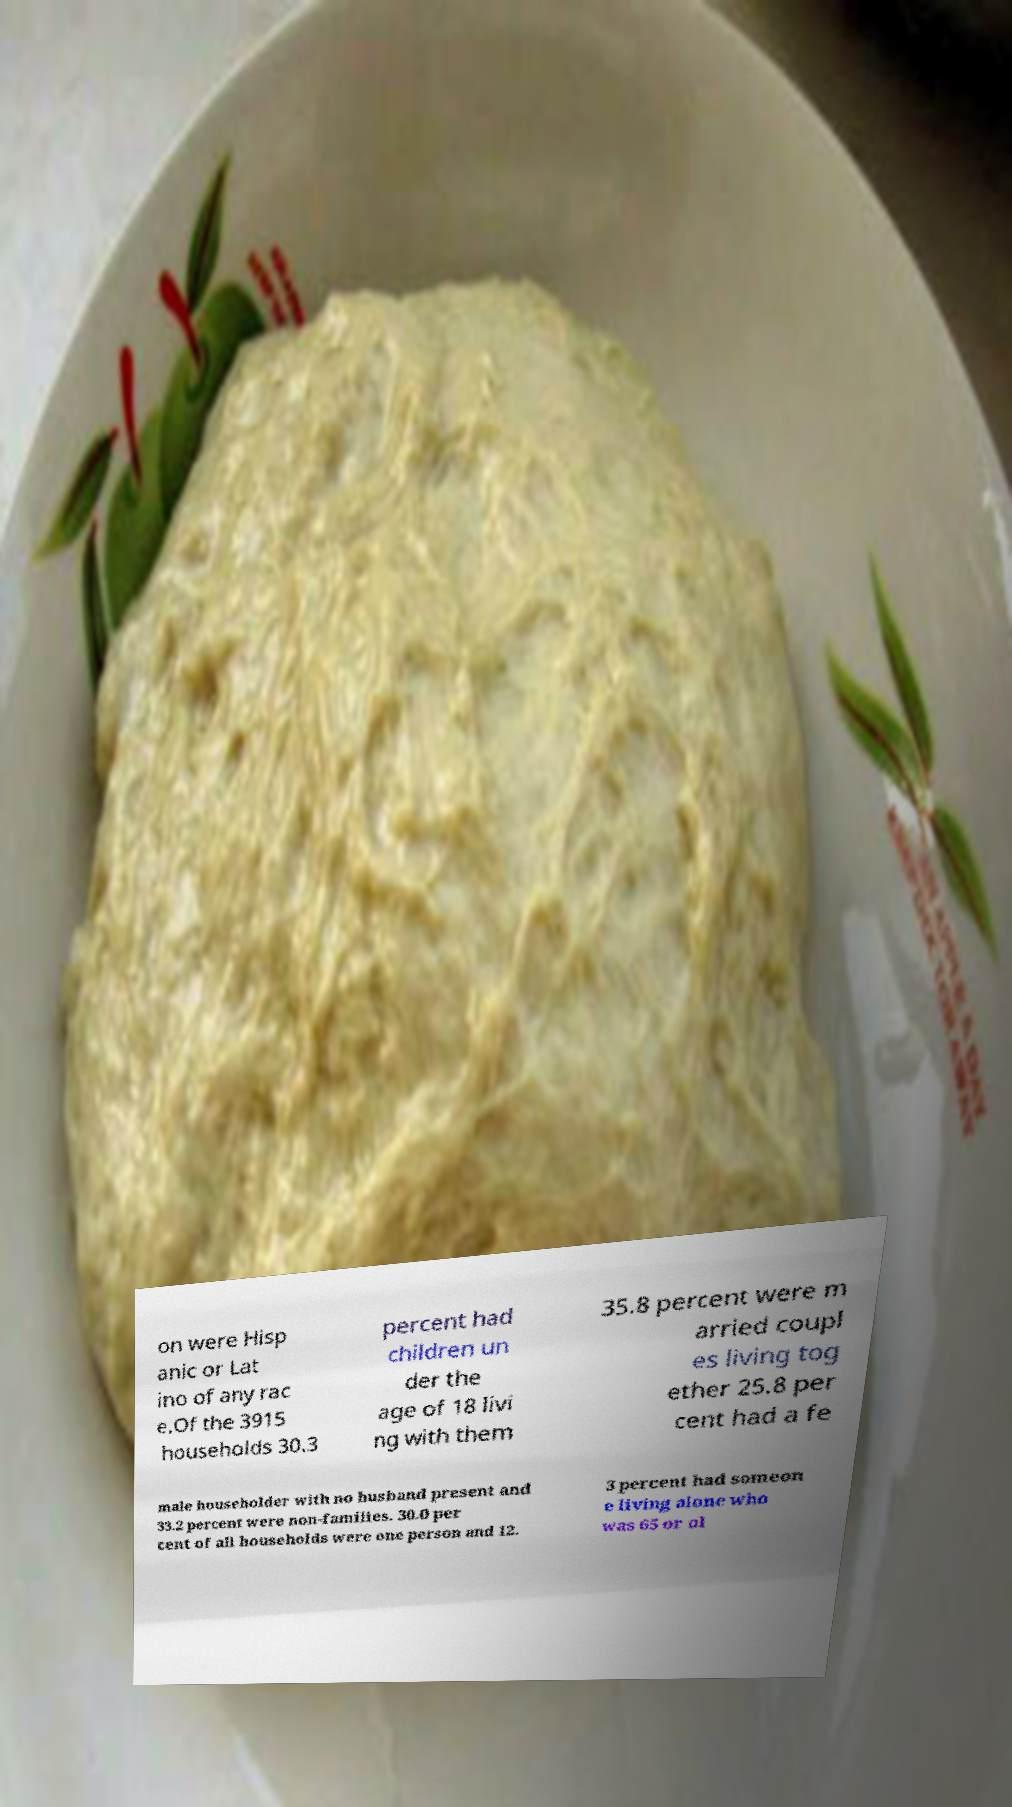Can you read and provide the text displayed in the image?This photo seems to have some interesting text. Can you extract and type it out for me? on were Hisp anic or Lat ino of any rac e.Of the 3915 households 30.3 percent had children un der the age of 18 livi ng with them 35.8 percent were m arried coupl es living tog ether 25.8 per cent had a fe male householder with no husband present and 33.2 percent were non-families. 30.0 per cent of all households were one person and 12. 3 percent had someon e living alone who was 65 or ol 